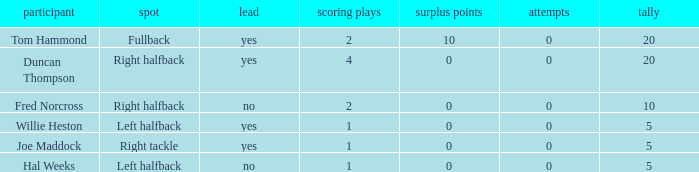How many touchdowns are there when there were 0 extra points and Hal Weeks had left halfback? 1.0. 